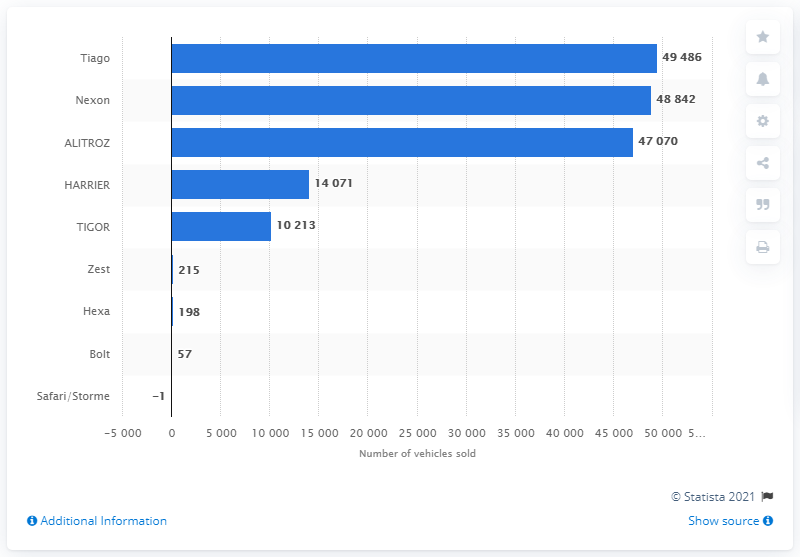Outline some significant characteristics in this image. In 2020, a total of 49,486 units of the Tata Tiago were sold in India. The subcompact hatchback launched by Tata Motors in 2020 was named "Alitroz. 